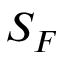<formula> <loc_0><loc_0><loc_500><loc_500>S _ { F }</formula> 